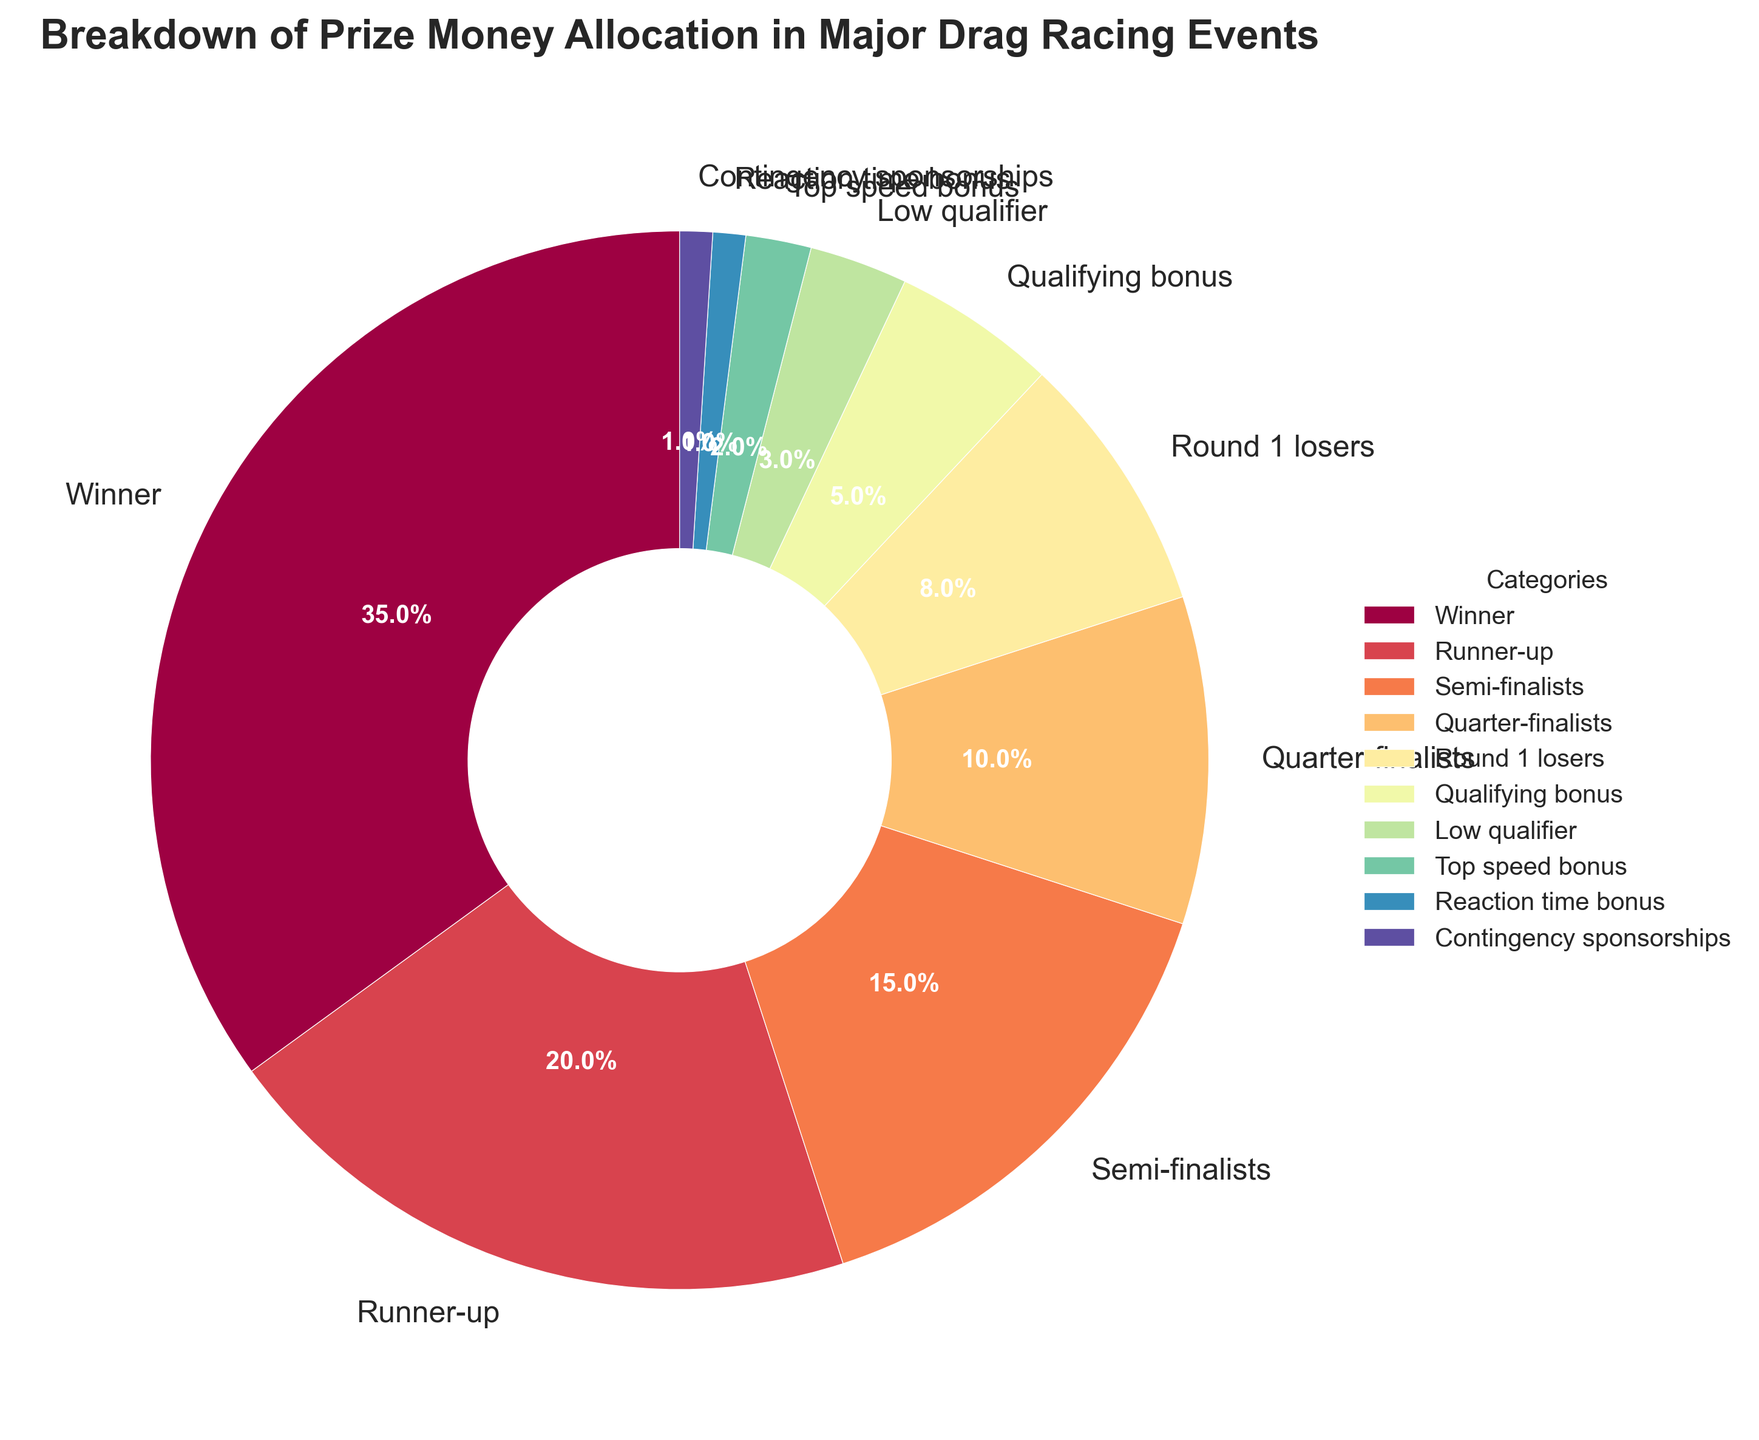What percentage of the prize money is allocated to the winner? According to the chart, the segment labeled "Winner" shows 35%, indicating that 35% of the prize money is allocated to the winner.
Answer: 35% What is the total combined percentage allocated to the Semi-finalists and Quarter-finalists? The segment labeled "Semi-finalists" shows 15% and the segment labeled "Quarter-finalists" shows 10%. Adding these two percentages together, 15% + 10% = 25%.
Answer: 25% Which category receives the least amount of prize money allocation? The "Reaction time bonus" and "Contingency sponsorships" segments both show 1%, indicating they receive the least amount of prize money allocation.
Answer: Reaction time bonus and Contingency sponsorships Is the prize money allocated to the Runner-up higher or lower than the combined allocation of Round 1 losers and the Qualifying bonus? According to the chart, the Runner-up receives 20%, while Round 1 losers receive 8% and Qualifying bonus receives 5%. The combined allocation of Round 1 losers and Qualifying bonus is 8% + 5% = 13%, which is lower than the Runner-up's 20%.
Answer: Higher How much more percentage does the Low qualifier receive than the Reaction time bonus? The Low qualifier receives 3% and the Reaction time bonus receives 1%. The difference is 3% - 1% = 2%.
Answer: 2% What is the combined percentage allocated to categories receiving less than 10%? The segments receiving less than 10% are Round 1 losers (8%), Qualifying bonus (5%), Low qualifier (3%), Top speed bonus (2%), Reaction time bonus (1%), and Contingency sponsorships (1%). Adding these together: 8% + 5% + 3% + 2% + 1% + 1% equals 20%.
Answer: 20% Which category receives more prize money, Top speed bonus or Round 1 losers? According to the chart, the Top speed bonus receives 2%, while Round 1 losers receive 8%. Therefore, Round 1 losers receive more prize money.
Answer: Round 1 losers How much more percentage is allocated to Semi-finalists and Runner-up combined compared to Low qualifier and Top speed bonus combined? Semi-finalists receive 15% and Runner-up receives 20%, summing to 35%. Low qualifier receives 3% and Top speed bonus receives 2%, summing to 5%. The difference is 35% - 5% = 30%.
Answer: 30% What percentage of the prize money allocation is not accounted for by the top three categories (Winner, Runner-up, Semi-finalists)? The top three categories (Winner, Runner-up, Semi-finalists) have percentages of 35%, 20%, and 15% respectively. Summing these: 35% + 20% + 15% = 70%. Therefore, the percentage not accounted for by these categories is 100% - 70% = 30%.
Answer: 30% What is the total combined percentage allocated to contingency sponsorships, reaction time bonus, and low qualifier categories? The segments labeled "Contingency sponsorships," "Reaction time bonus," and "Low qualifier" show 1%, 1%, and 3% respectively. Adding these percentages together, 1% + 1% + 3% = 5%.
Answer: 5% 